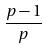<formula> <loc_0><loc_0><loc_500><loc_500>\frac { p - 1 } { p }</formula> 